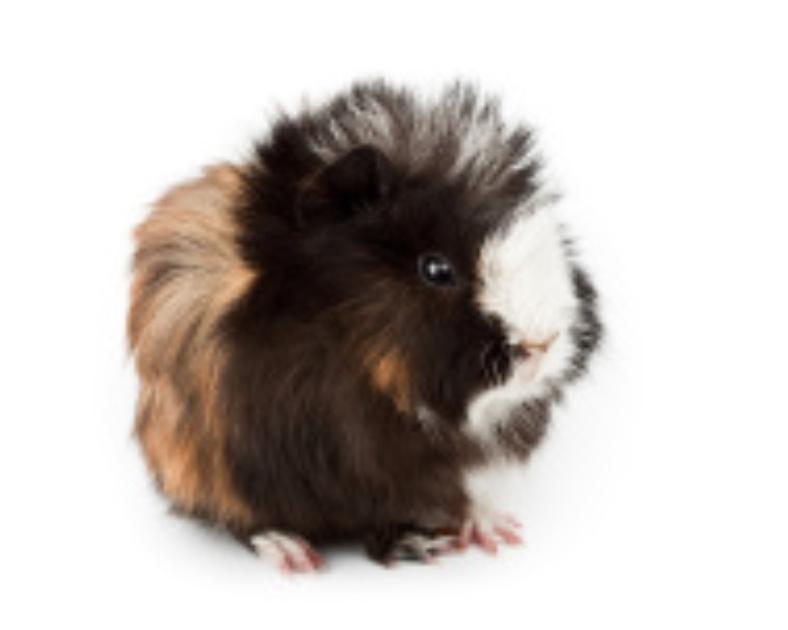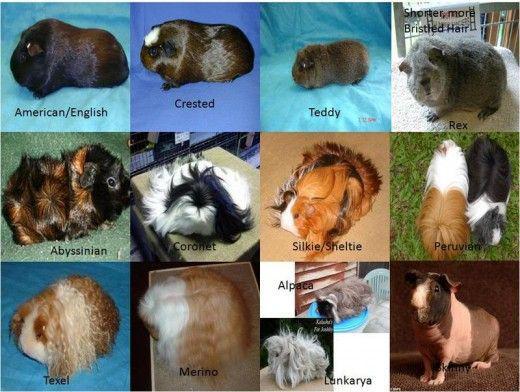The first image is the image on the left, the second image is the image on the right. Evaluate the accuracy of this statement regarding the images: "One image shows real guinea pigs of various types with different fur styles, and the other image contains just one figure with a guinea pig face.". Is it true? Answer yes or no. Yes. 